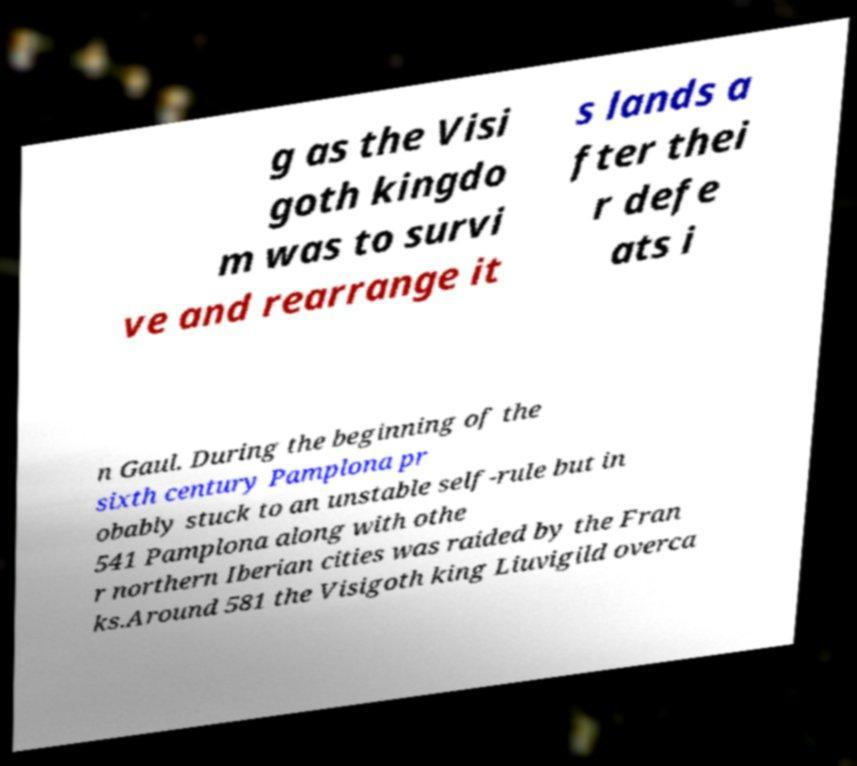Please read and relay the text visible in this image. What does it say? g as the Visi goth kingdo m was to survi ve and rearrange it s lands a fter thei r defe ats i n Gaul. During the beginning of the sixth century Pamplona pr obably stuck to an unstable self-rule but in 541 Pamplona along with othe r northern Iberian cities was raided by the Fran ks.Around 581 the Visigoth king Liuvigild overca 